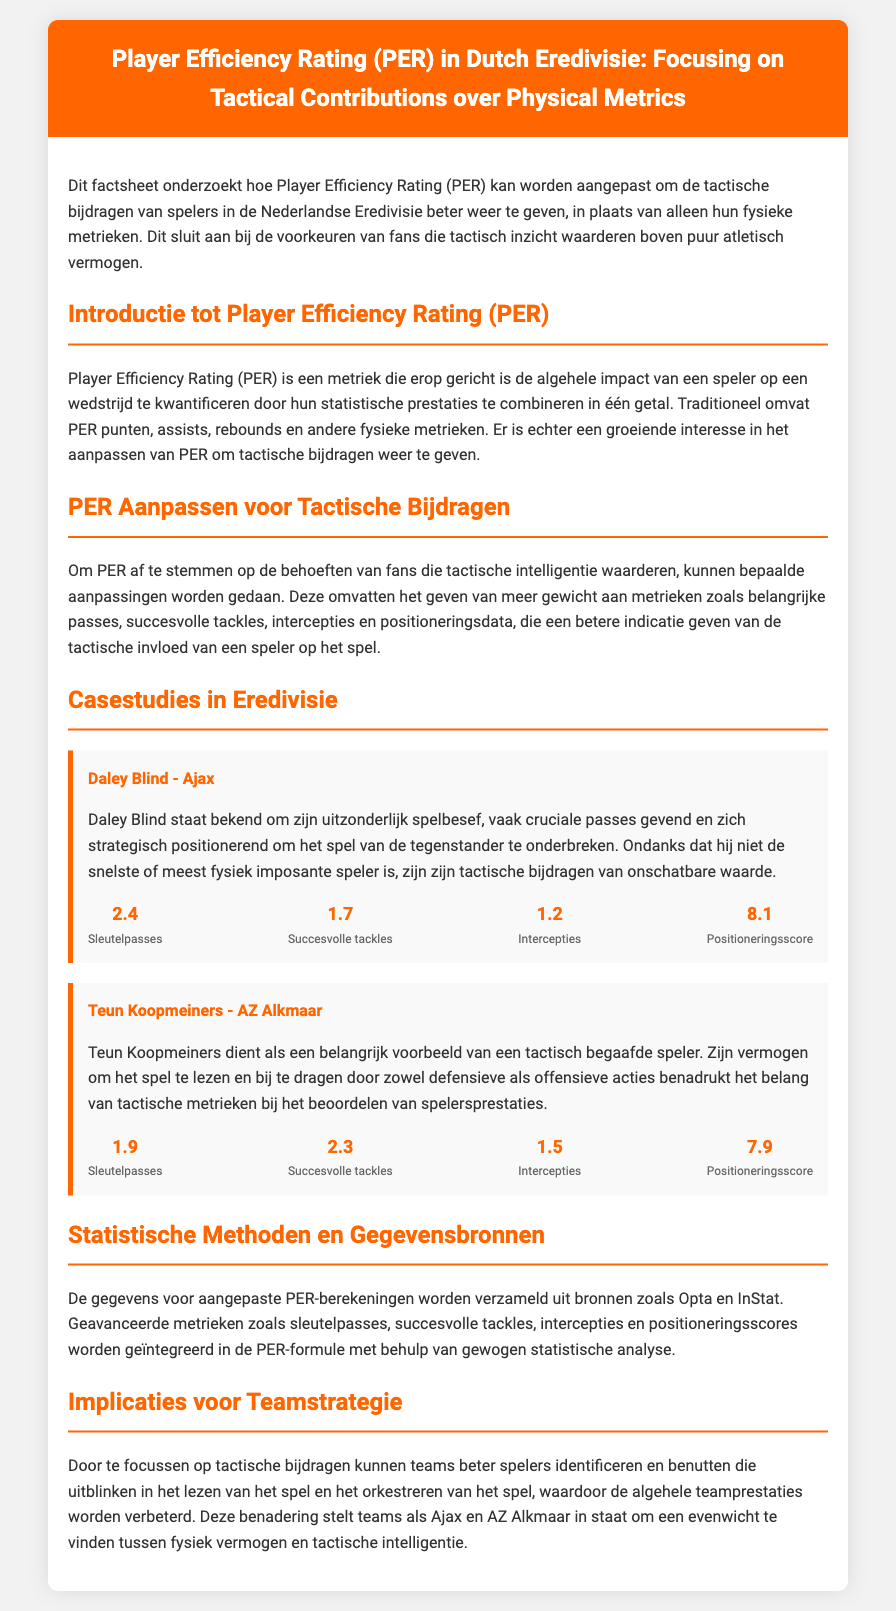wat is de volledige titel van het document? De volledige titel van het document is "Player Efficiency Rating (PER) in Dutch Eredivisie: Focusing on Tactical Contributions over Physical Metrics."
Answer: Player Efficiency Rating (PER) in Dutch Eredivisie: Focusing on Tactical Contributions over Physical Metrics wie is een voorbeeldspeler die tactische bijdragen levert? Een voorbeeldspeler die tactische bijdragen levert, volgens het document, is Daley Blind.
Answer: Daley Blind wat is de gemiddelde waarde van sleutelpasses voor Teun Koopmeiners? De gemiddelde waarde van sleutelpasses voor Teun Koopmeiners is 1.9.
Answer: 1.9 hoeveel succesvolle tackles heeft Daley Blind? Daley Blind heeft 1.7 succesvolle tackles.
Answer: 1.7 welke geavanceerde bron wordt gebruikt voor gegevensverzameling? Opta is een geavanceerde bron die wordt gebruikt voor gegevensverzameling.
Answer: Opta wat benadrukt de benadering van PER aanpassing? De benadering benadrukt het belang van tactische metrieken bij het beoordelen van spelersprestaties.
Answer: belangrijkheid van tactische metrieken hoeveel intercepties heeft Teun Koopmeiners? Teun Koopmeiners heeft 1.5 intercepties.
Answer: 1.5 welke kleur heeft de titel van de header? De kleur van de titel van de header is wit.
Answer: wit wat is de positioneringsscore van Daley Blind? De positioneringsscore van Daley Blind is 8.1.
Answer: 8.1 